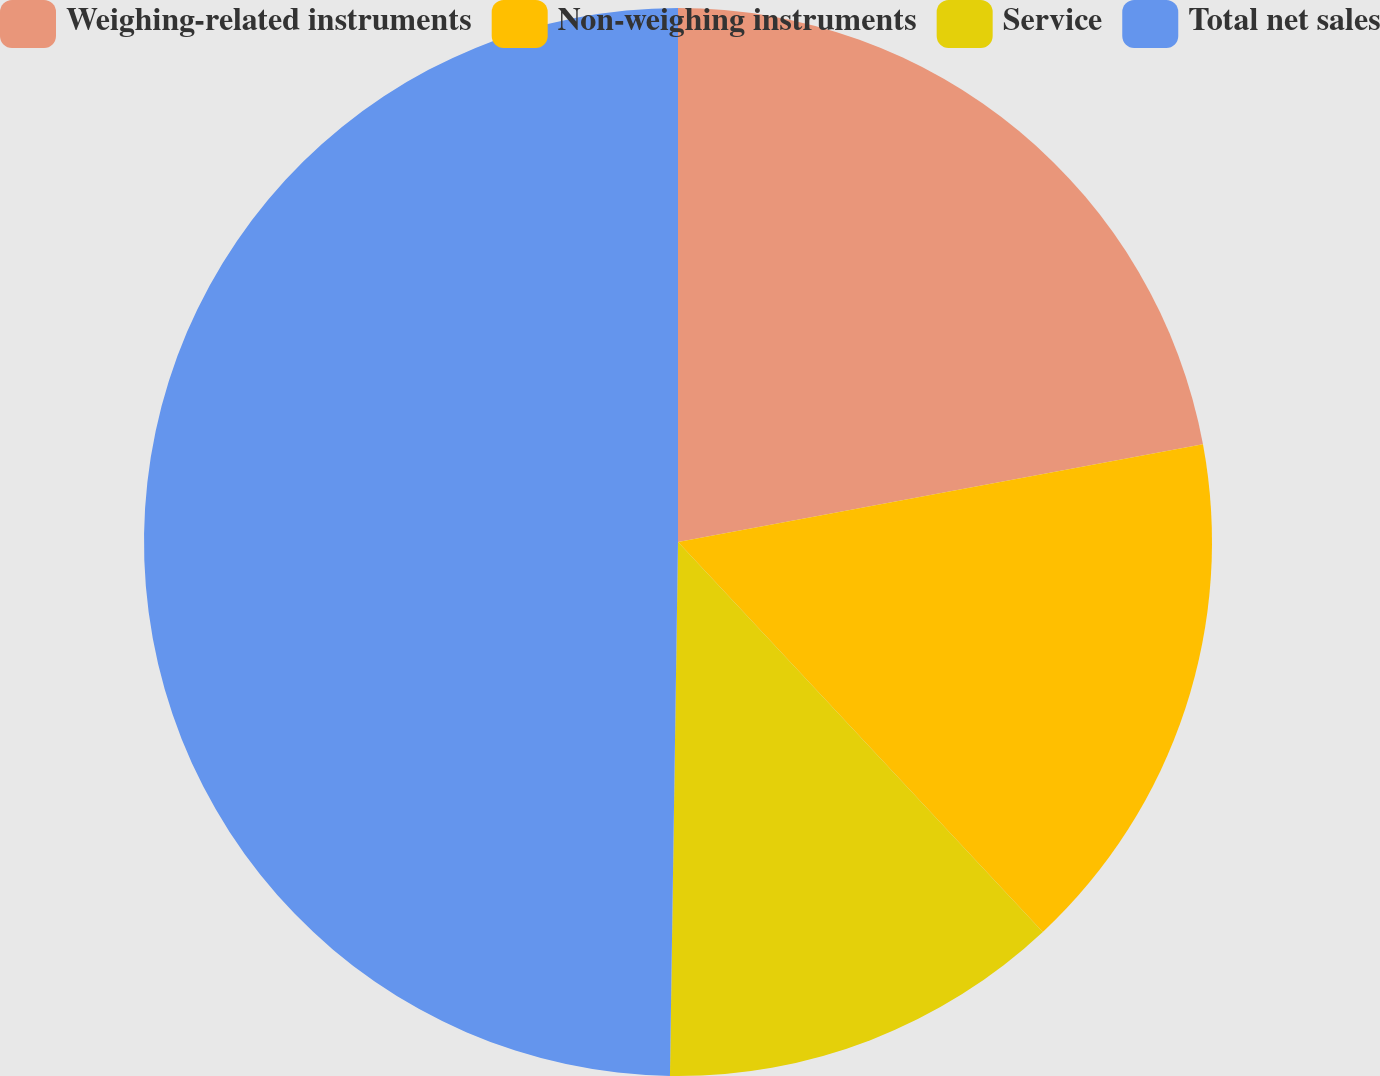<chart> <loc_0><loc_0><loc_500><loc_500><pie_chart><fcel>Weighing-related instruments<fcel>Non-weighing instruments<fcel>Service<fcel>Total net sales<nl><fcel>22.07%<fcel>15.96%<fcel>12.21%<fcel>49.76%<nl></chart> 